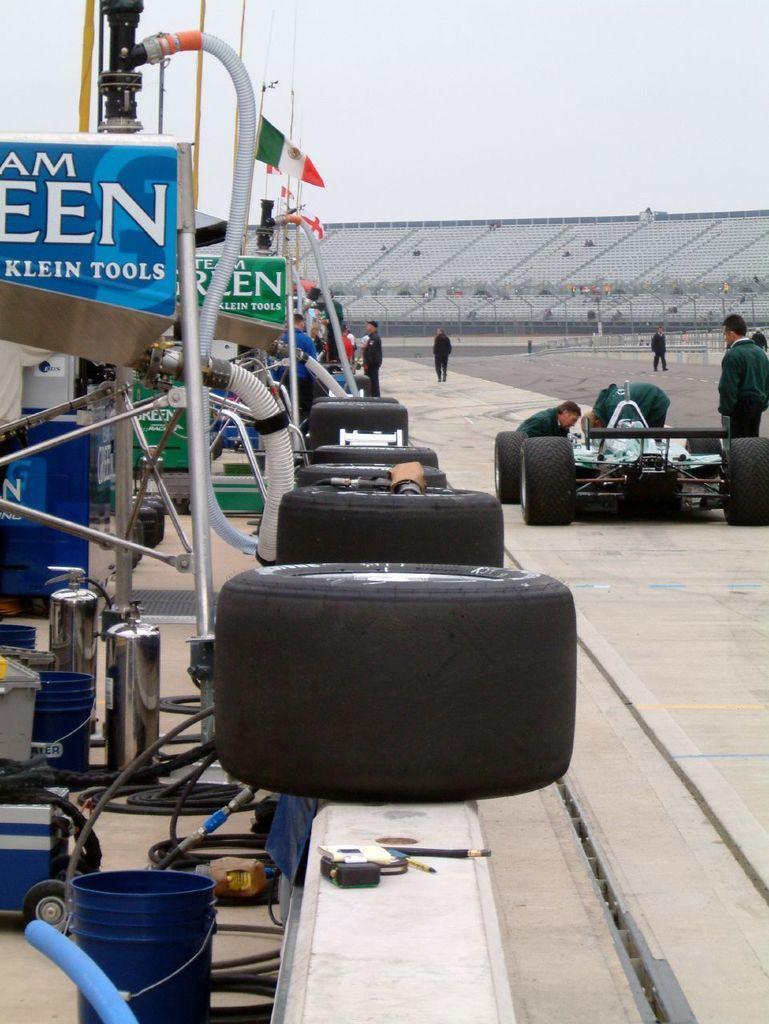In one or two sentences, can you explain what this image depicts? In this image, on the right, there is a vehicle on the road and some people are there and on the left, we can see tires, machines, and some wires. 